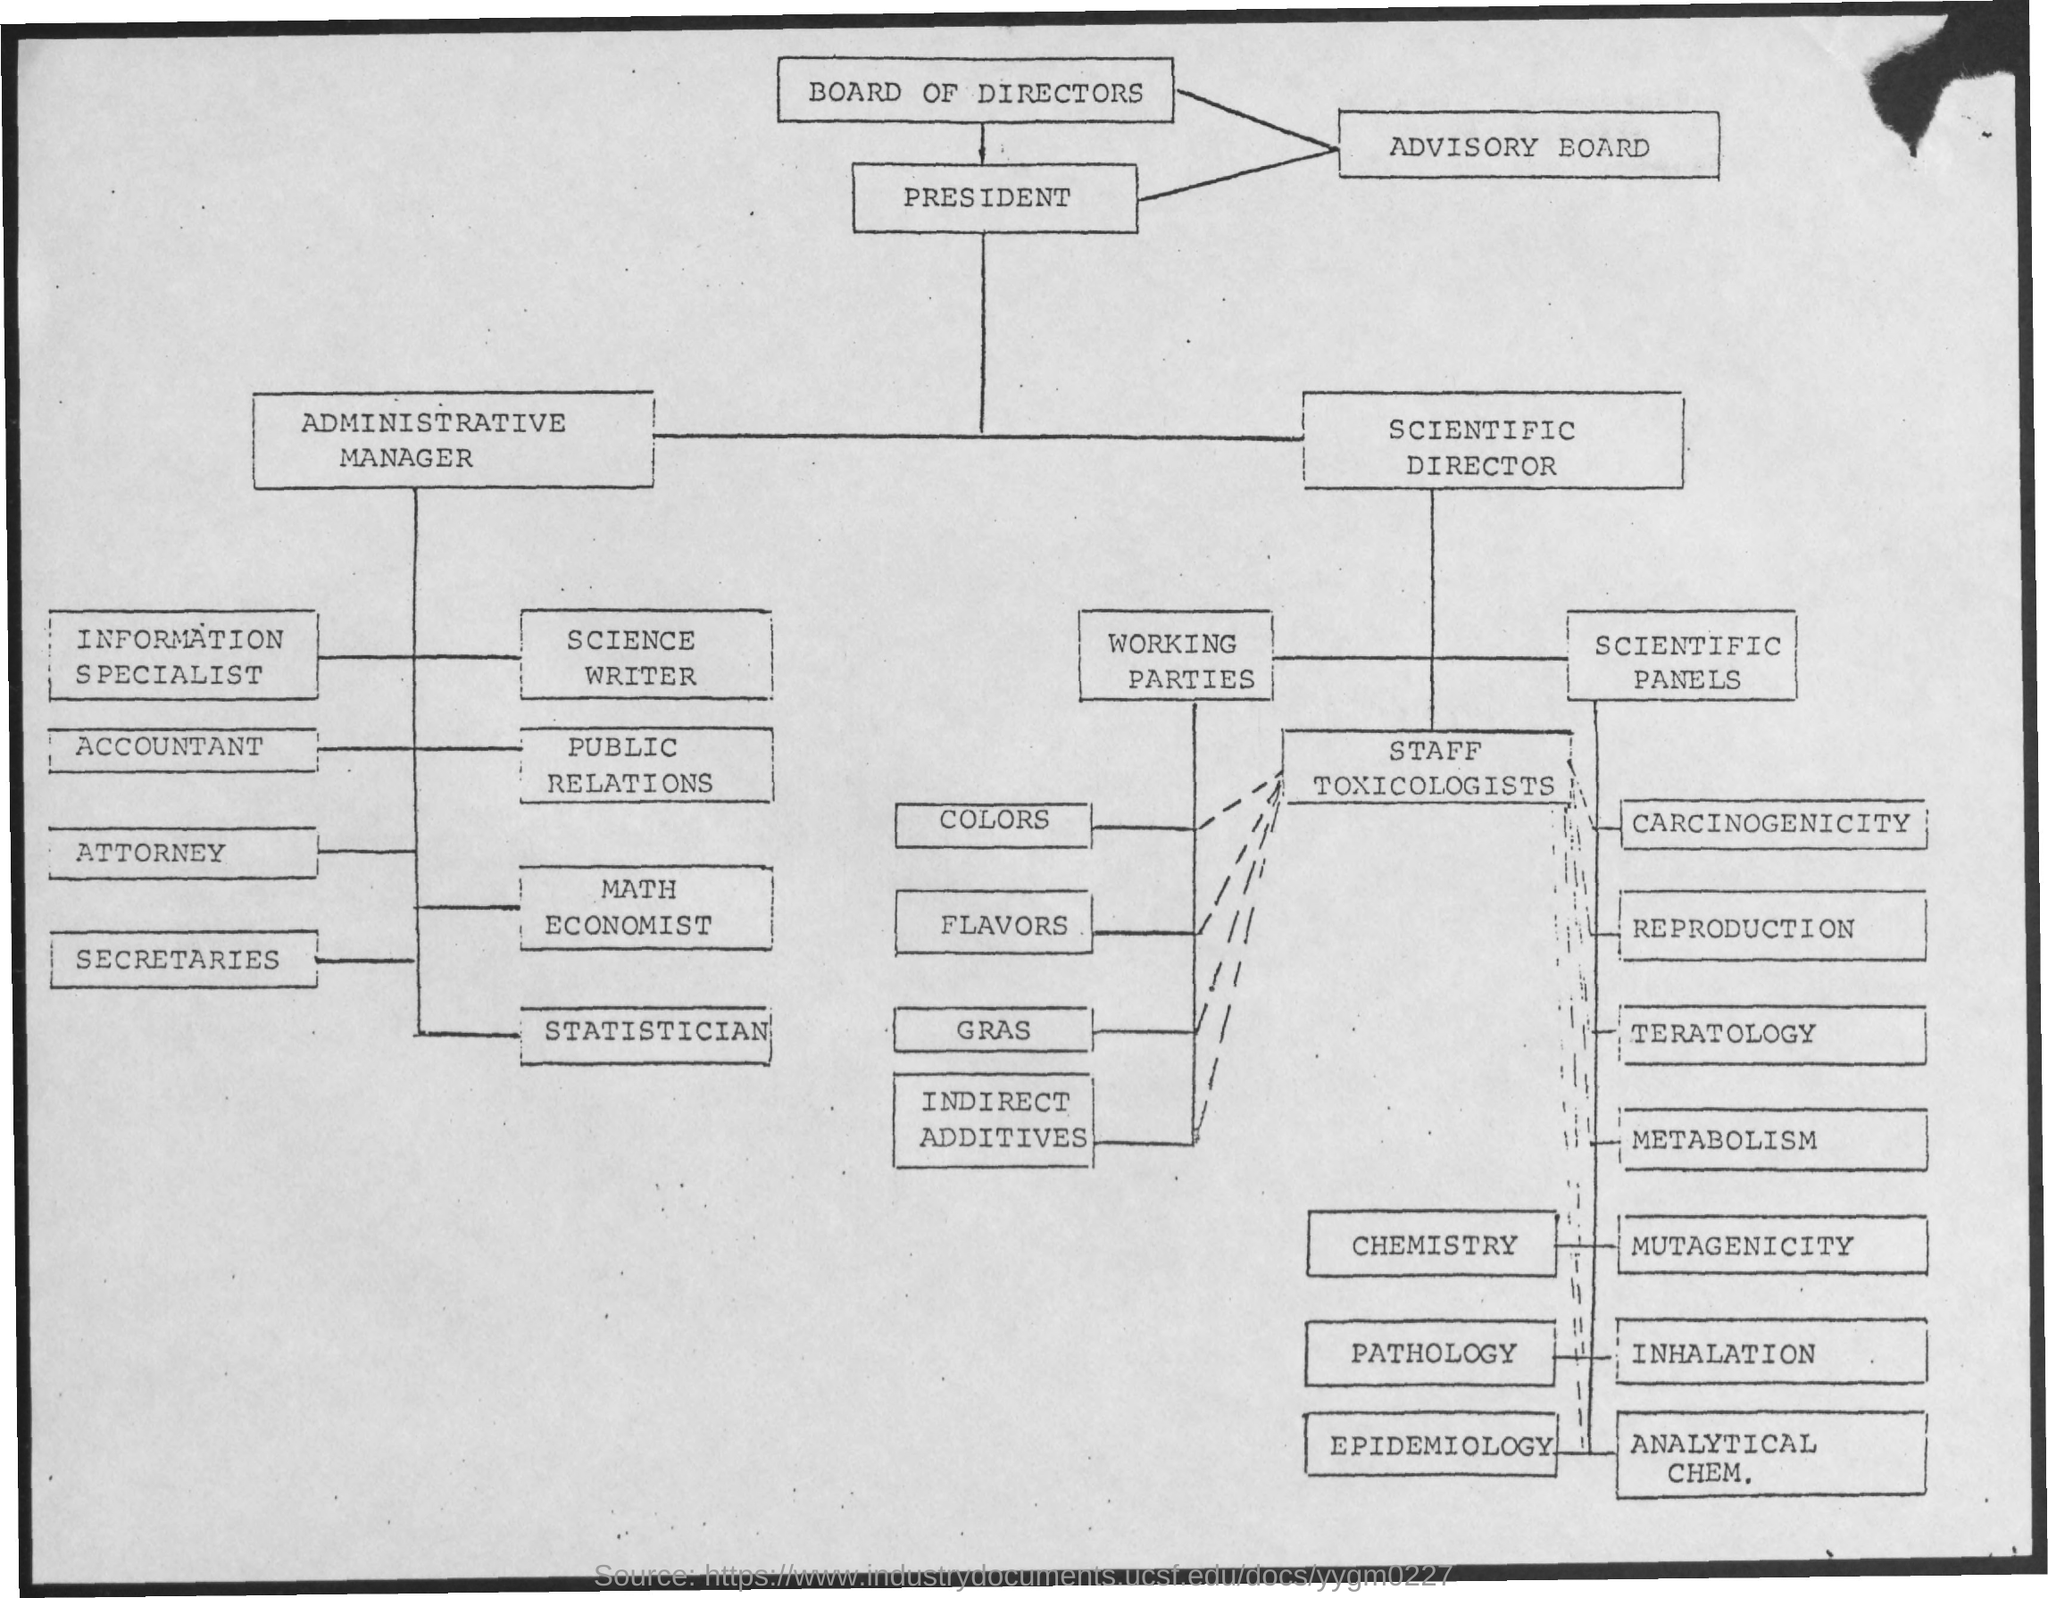Which text is in the first box?
Offer a very short reply. Board of Directors. 